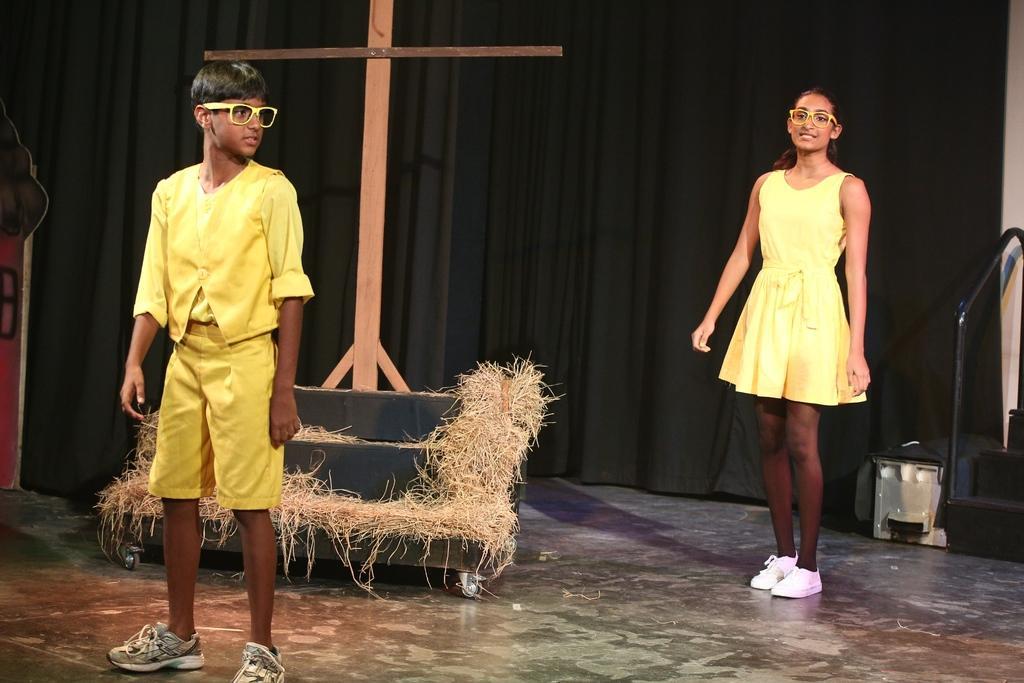In one or two sentences, can you explain what this image depicts? In this image there are two people standing. They are wearing yellow costumes. In the center we can see cross and grass. In the background there is a curtain and we can see stairs. 